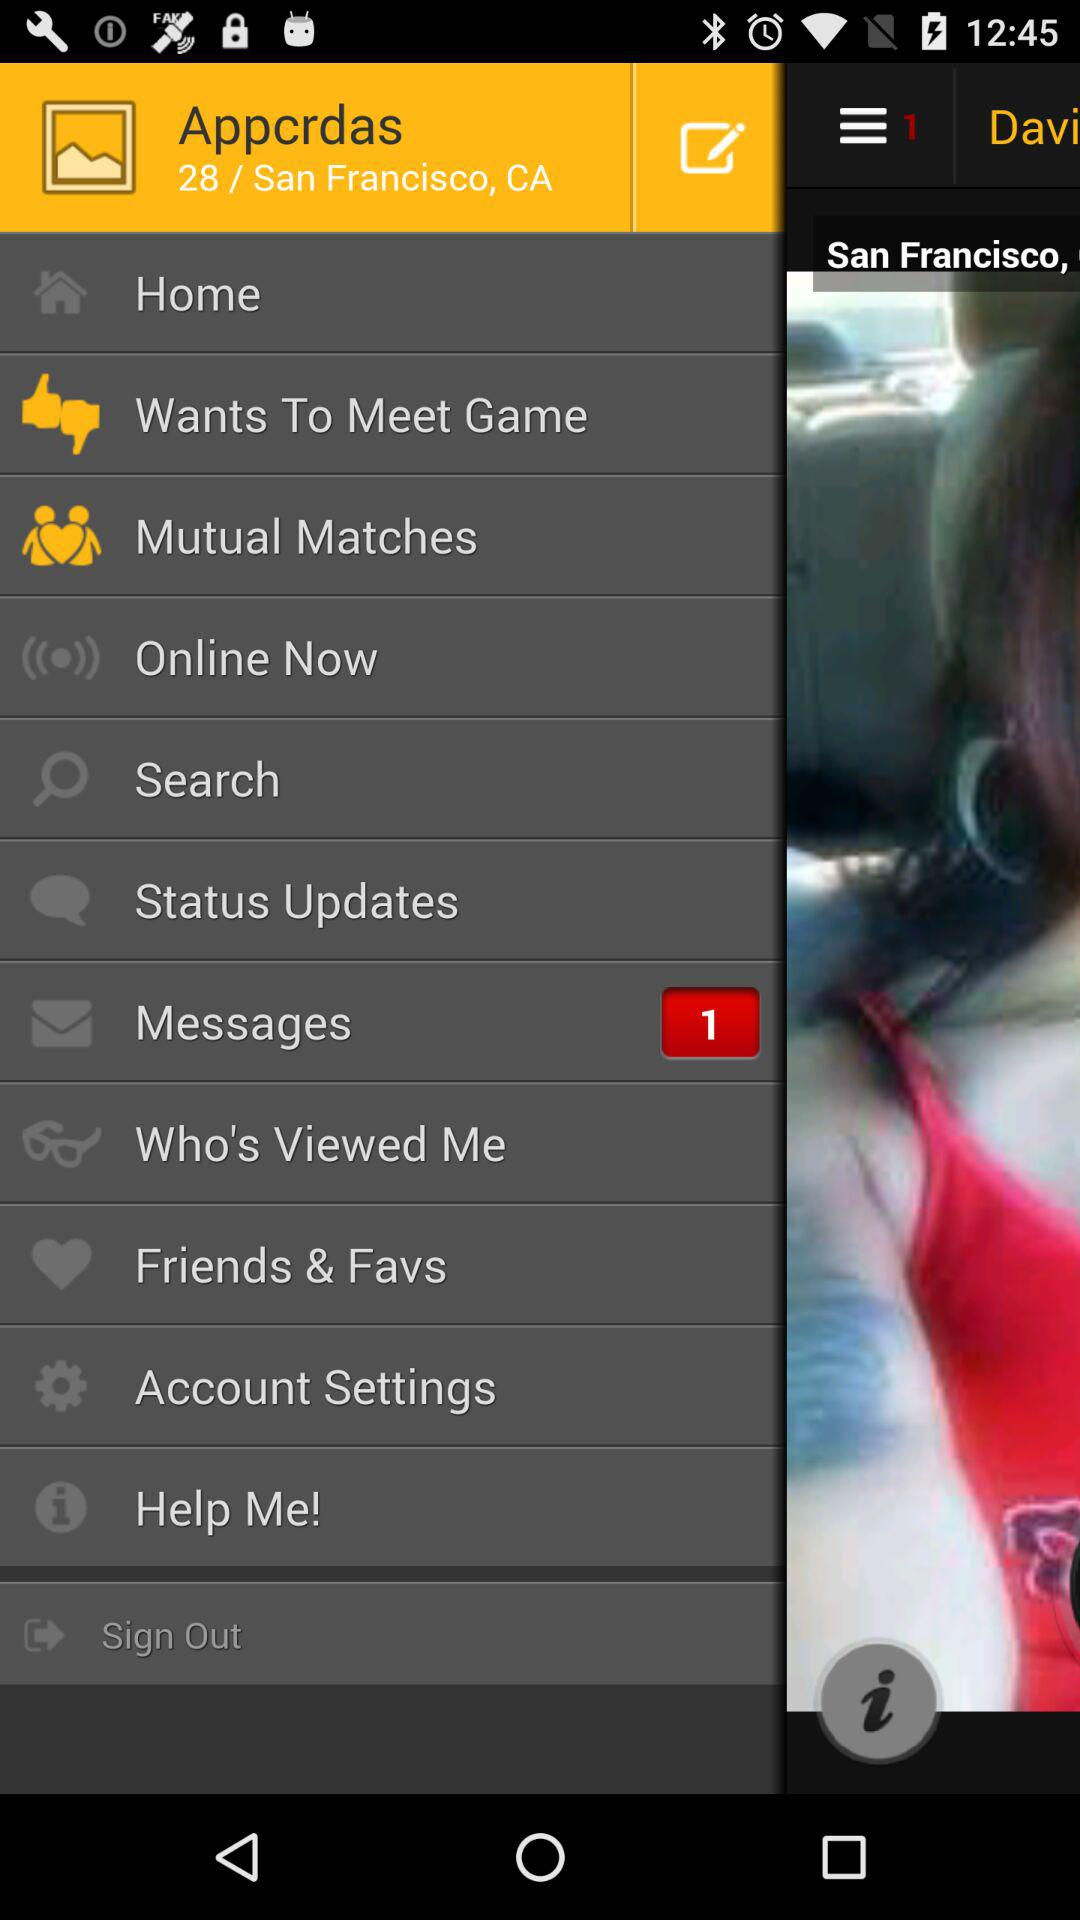What city is mentioned? The mentioned city is San Francisco. 